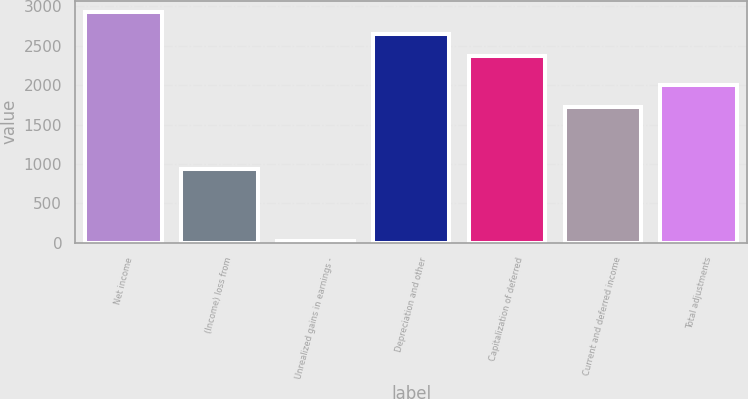<chart> <loc_0><loc_0><loc_500><loc_500><bar_chart><fcel>Net income<fcel>(Income) loss from<fcel>Unrealized gains in earnings -<fcel>Depreciation and other<fcel>Capitalization of deferred<fcel>Current and deferred income<fcel>Total adjustments<nl><fcel>2927.8<fcel>932<fcel>20<fcel>2647.4<fcel>2367<fcel>1728<fcel>2008.4<nl></chart> 